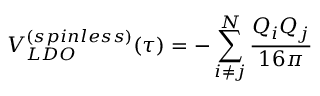<formula> <loc_0><loc_0><loc_500><loc_500>V _ { L D O } ^ { ( s p i n l e s s ) } ( \tau ) = - \sum _ { i \neq j } ^ { N } { \frac { Q _ { i } Q _ { j } } { 1 6 \pi } }</formula> 